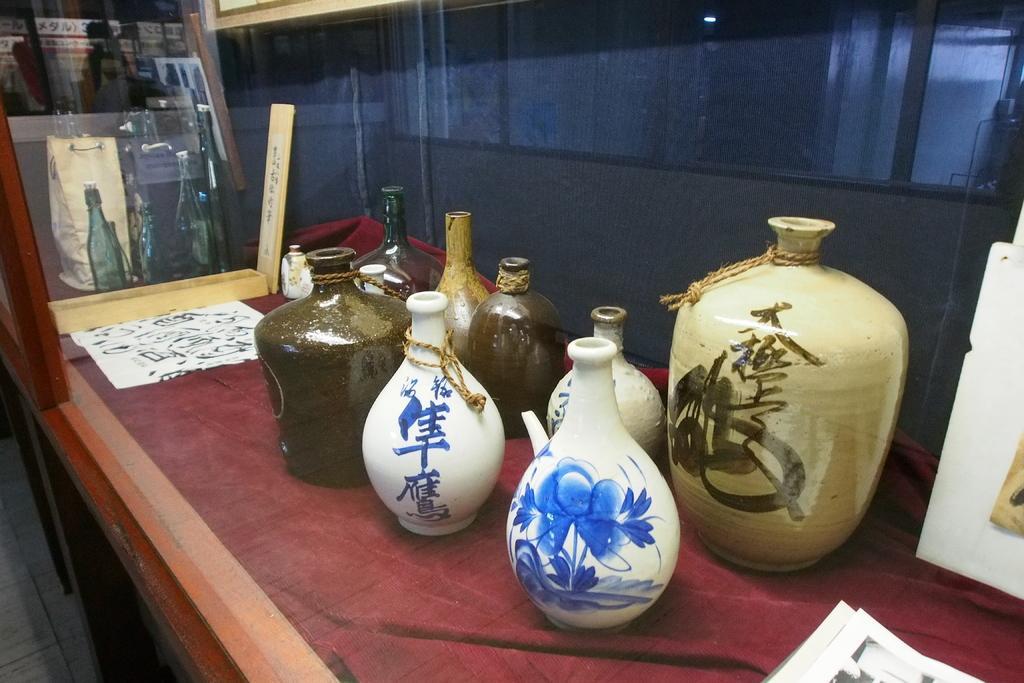Please provide a concise description of this image. This picture is mainly highlighted with a painted pots on a table. These are papers. This is a reflection of pots on a glass. 